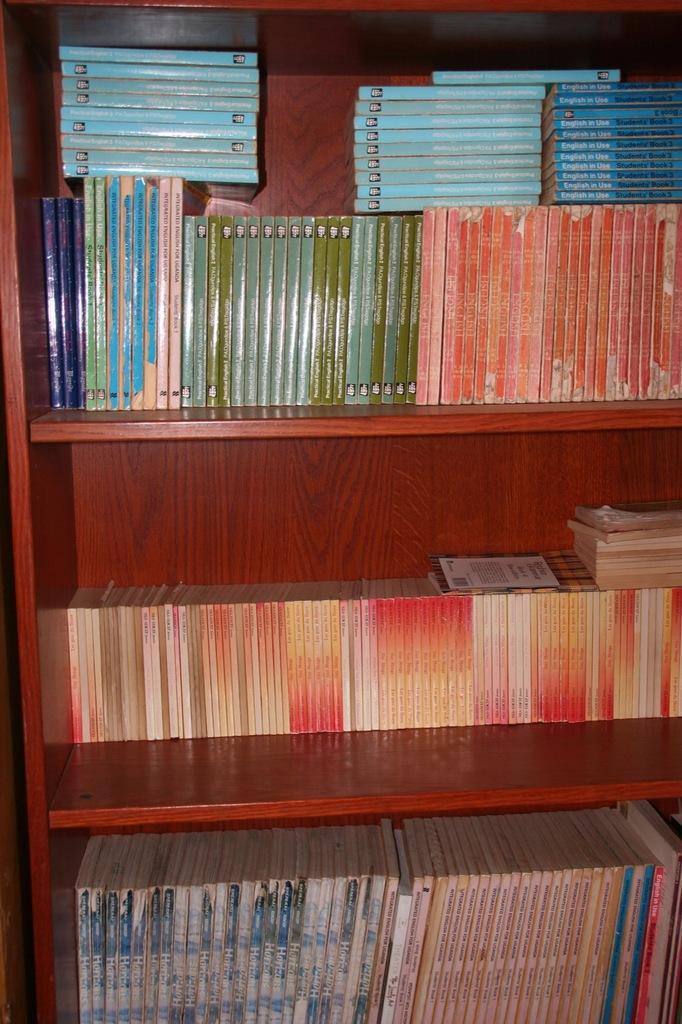Can you describe this image briefly? In this image I can see a bookshelf which is brown and orange in color and in the shelf I can see number of books which are blue, orange, green, red and cream in color. 